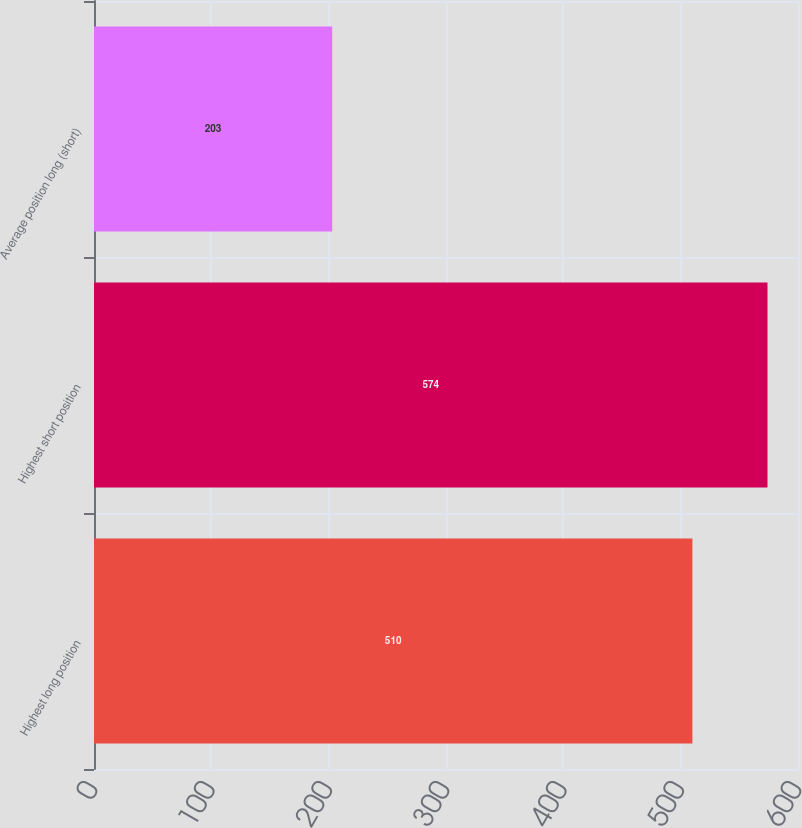Convert chart. <chart><loc_0><loc_0><loc_500><loc_500><bar_chart><fcel>Highest long position<fcel>Highest short position<fcel>Average position long (short)<nl><fcel>510<fcel>574<fcel>203<nl></chart> 